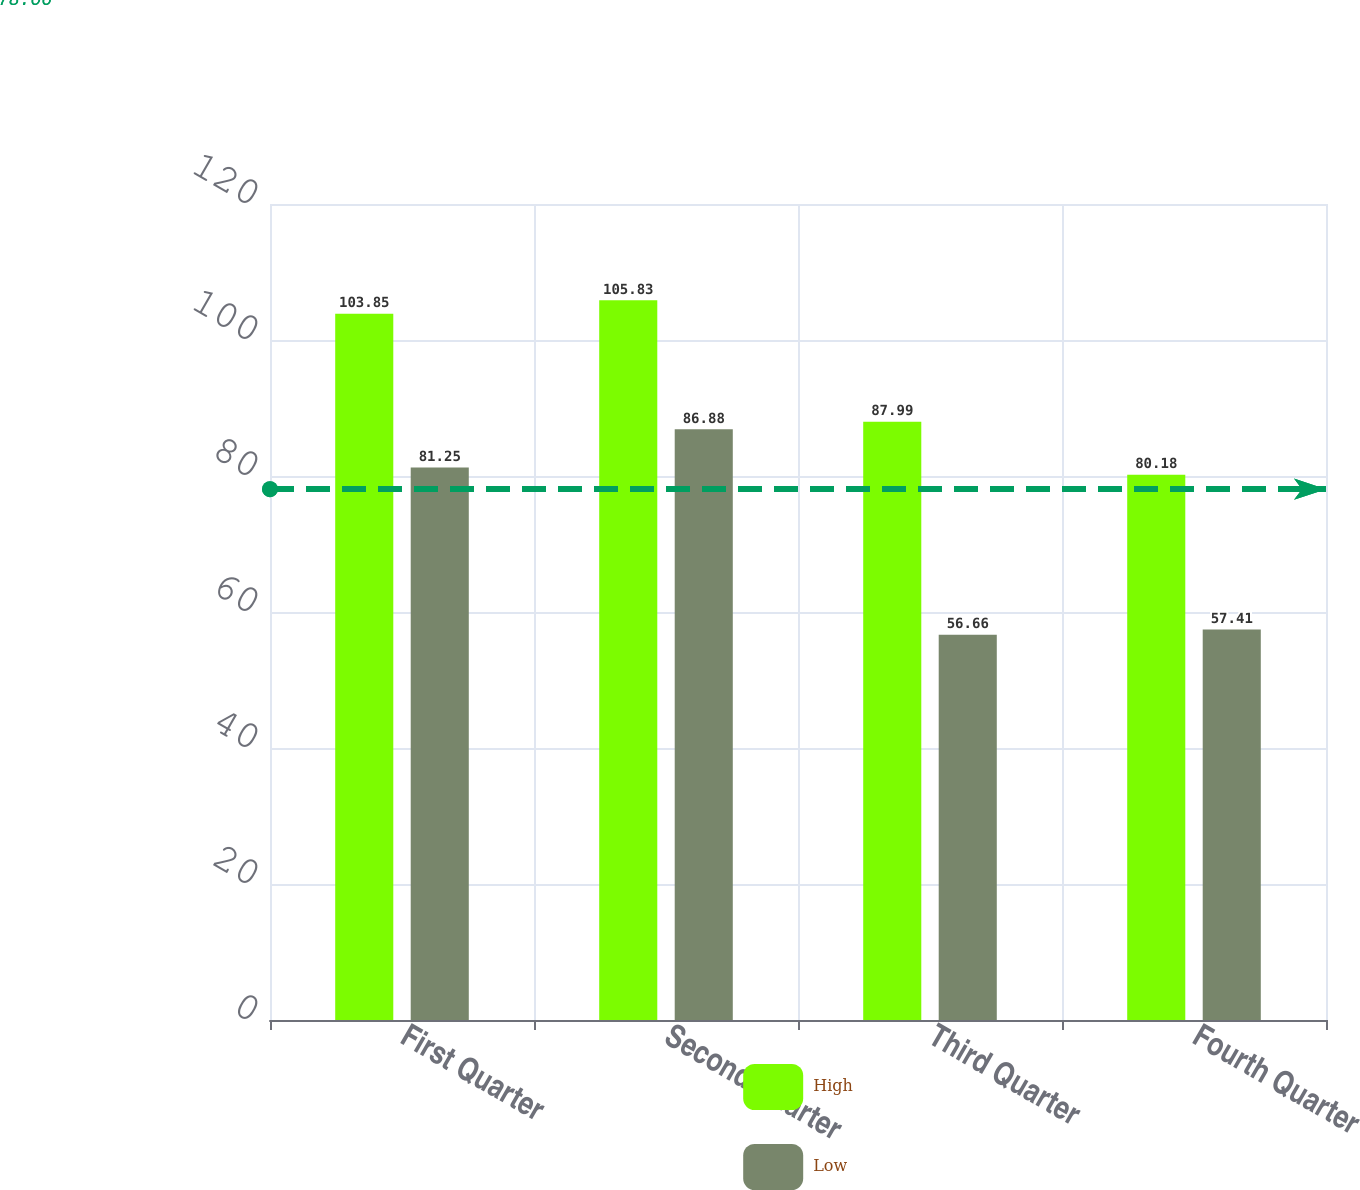Convert chart. <chart><loc_0><loc_0><loc_500><loc_500><stacked_bar_chart><ecel><fcel>First Quarter<fcel>Second Quarter<fcel>Third Quarter<fcel>Fourth Quarter<nl><fcel>High<fcel>103.85<fcel>105.83<fcel>87.99<fcel>80.18<nl><fcel>Low<fcel>81.25<fcel>86.88<fcel>56.66<fcel>57.41<nl></chart> 